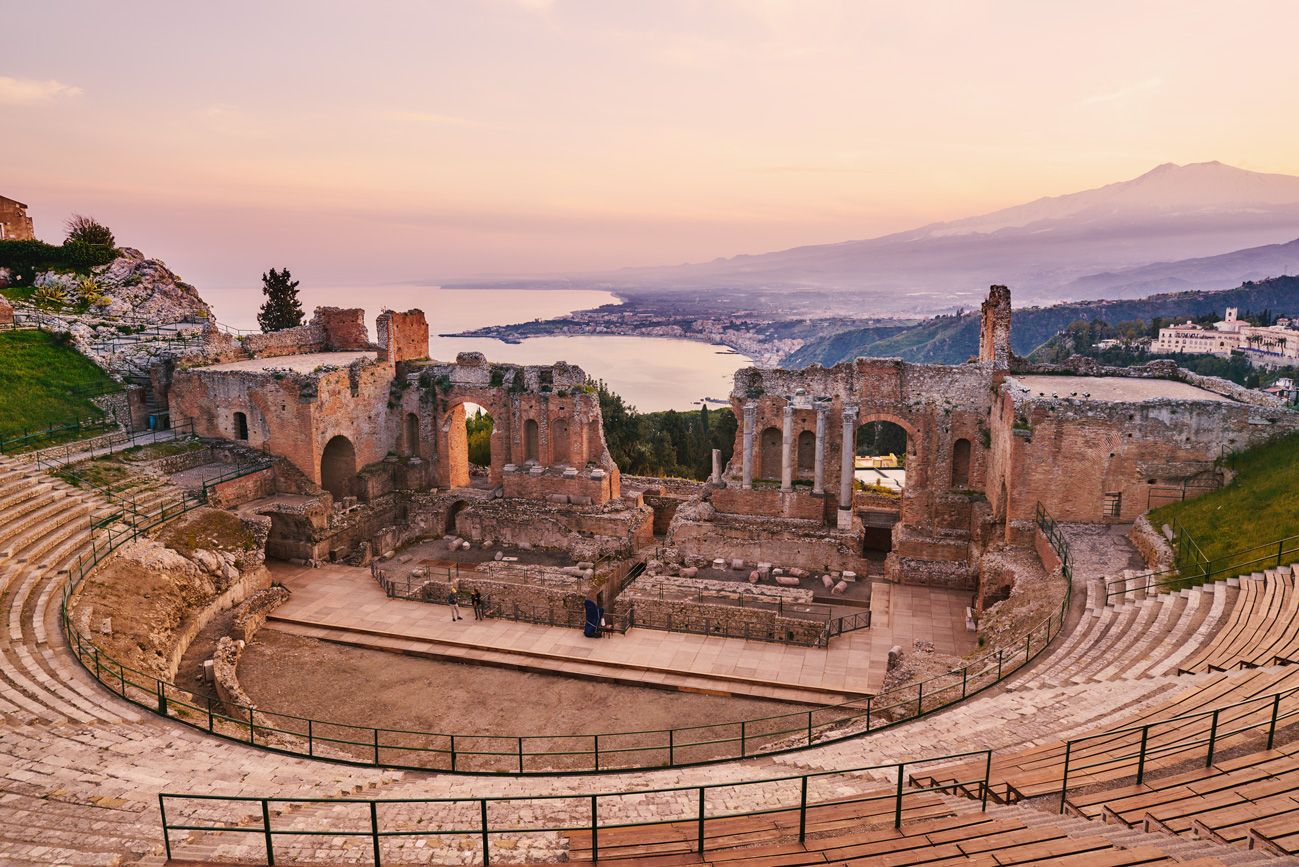What is the significance of Mount Etna in the background? Mount Etna is not just a dramatic backdrop but is deeply entwined with Sicilian culture and mythology. Historically, it's been both a boon and bane to the locals, fertile from volcanic soils yet devastating when eruptive. For the theater, Etna stands as a majestic natural setting, enhancing the aesthetic value and the dramatic effect of performances, while symbolizing the powerful natural forces that have shaped Sicilyís landscape and life. 